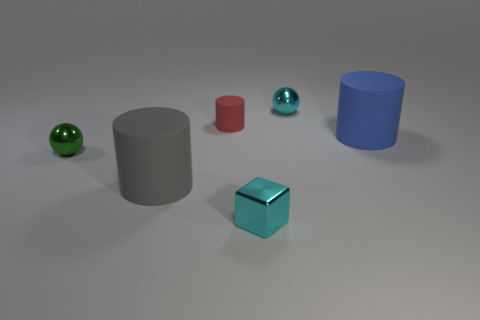What is the size of the matte cylinder that is in front of the large blue cylinder that is behind the green metallic ball?
Your answer should be very brief. Large. How many objects are big brown metal things or cyan metal spheres?
Give a very brief answer. 1. Are there any small spheres of the same color as the tiny metal cube?
Your answer should be compact. Yes. Is the number of big brown rubber cylinders less than the number of big blue rubber cylinders?
Offer a very short reply. Yes. How many things are green metallic spheres or blue cylinders in front of the tiny red rubber thing?
Ensure brevity in your answer.  2. Is there another big cyan block that has the same material as the cyan cube?
Give a very brief answer. No. There is another sphere that is the same size as the cyan sphere; what is it made of?
Offer a terse response. Metal. There is a cyan object to the left of the small sphere behind the green ball; what is its material?
Your answer should be compact. Metal. Is the shape of the tiny cyan shiny object that is behind the big gray thing the same as  the green metal object?
Make the answer very short. Yes. What is the color of the large cylinder that is the same material as the big gray thing?
Provide a short and direct response. Blue. 